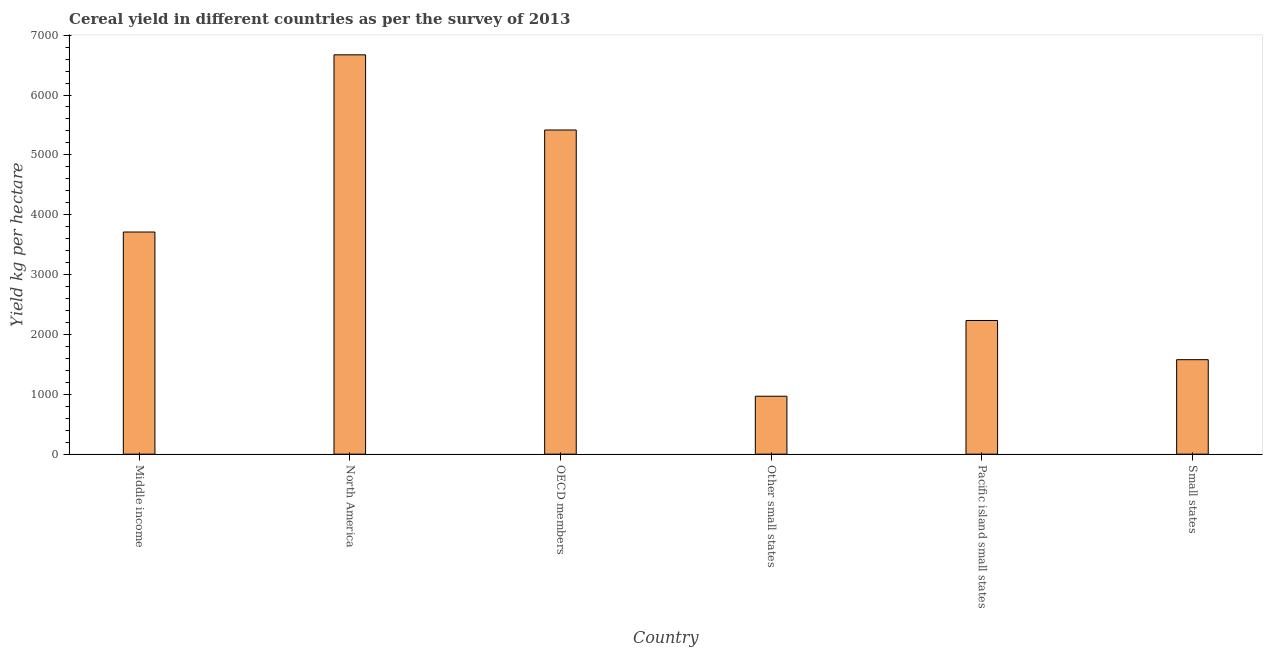Does the graph contain any zero values?
Ensure brevity in your answer.  No. Does the graph contain grids?
Provide a succinct answer. No. What is the title of the graph?
Your answer should be very brief. Cereal yield in different countries as per the survey of 2013. What is the label or title of the Y-axis?
Your answer should be compact. Yield kg per hectare. What is the cereal yield in Middle income?
Make the answer very short. 3710.98. Across all countries, what is the maximum cereal yield?
Ensure brevity in your answer.  6671.01. Across all countries, what is the minimum cereal yield?
Ensure brevity in your answer.  967.55. In which country was the cereal yield maximum?
Offer a very short reply. North America. In which country was the cereal yield minimum?
Offer a very short reply. Other small states. What is the sum of the cereal yield?
Make the answer very short. 2.06e+04. What is the difference between the cereal yield in Middle income and Pacific island small states?
Give a very brief answer. 1477.82. What is the average cereal yield per country?
Ensure brevity in your answer.  3429.4. What is the median cereal yield?
Make the answer very short. 2972.07. What is the ratio of the cereal yield in Middle income to that in Pacific island small states?
Make the answer very short. 1.66. Is the difference between the cereal yield in OECD members and Small states greater than the difference between any two countries?
Provide a succinct answer. No. What is the difference between the highest and the second highest cereal yield?
Provide a short and direct response. 1255.74. What is the difference between the highest and the lowest cereal yield?
Your response must be concise. 5703.47. In how many countries, is the cereal yield greater than the average cereal yield taken over all countries?
Provide a succinct answer. 3. How many countries are there in the graph?
Your response must be concise. 6. Are the values on the major ticks of Y-axis written in scientific E-notation?
Offer a very short reply. No. What is the Yield kg per hectare of Middle income?
Offer a very short reply. 3710.98. What is the Yield kg per hectare of North America?
Give a very brief answer. 6671.01. What is the Yield kg per hectare of OECD members?
Offer a very short reply. 5415.27. What is the Yield kg per hectare in Other small states?
Provide a short and direct response. 967.55. What is the Yield kg per hectare in Pacific island small states?
Keep it short and to the point. 2233.17. What is the Yield kg per hectare of Small states?
Give a very brief answer. 1578.43. What is the difference between the Yield kg per hectare in Middle income and North America?
Your answer should be compact. -2960.03. What is the difference between the Yield kg per hectare in Middle income and OECD members?
Ensure brevity in your answer.  -1704.29. What is the difference between the Yield kg per hectare in Middle income and Other small states?
Your response must be concise. 2743.44. What is the difference between the Yield kg per hectare in Middle income and Pacific island small states?
Give a very brief answer. 1477.82. What is the difference between the Yield kg per hectare in Middle income and Small states?
Provide a short and direct response. 2132.55. What is the difference between the Yield kg per hectare in North America and OECD members?
Keep it short and to the point. 1255.74. What is the difference between the Yield kg per hectare in North America and Other small states?
Offer a terse response. 5703.47. What is the difference between the Yield kg per hectare in North America and Pacific island small states?
Provide a short and direct response. 4437.85. What is the difference between the Yield kg per hectare in North America and Small states?
Your response must be concise. 5092.58. What is the difference between the Yield kg per hectare in OECD members and Other small states?
Ensure brevity in your answer.  4447.72. What is the difference between the Yield kg per hectare in OECD members and Pacific island small states?
Offer a very short reply. 3182.1. What is the difference between the Yield kg per hectare in OECD members and Small states?
Provide a succinct answer. 3836.84. What is the difference between the Yield kg per hectare in Other small states and Pacific island small states?
Offer a very short reply. -1265.62. What is the difference between the Yield kg per hectare in Other small states and Small states?
Give a very brief answer. -610.89. What is the difference between the Yield kg per hectare in Pacific island small states and Small states?
Keep it short and to the point. 654.73. What is the ratio of the Yield kg per hectare in Middle income to that in North America?
Provide a succinct answer. 0.56. What is the ratio of the Yield kg per hectare in Middle income to that in OECD members?
Your response must be concise. 0.69. What is the ratio of the Yield kg per hectare in Middle income to that in Other small states?
Your answer should be compact. 3.83. What is the ratio of the Yield kg per hectare in Middle income to that in Pacific island small states?
Offer a very short reply. 1.66. What is the ratio of the Yield kg per hectare in Middle income to that in Small states?
Your answer should be compact. 2.35. What is the ratio of the Yield kg per hectare in North America to that in OECD members?
Your answer should be very brief. 1.23. What is the ratio of the Yield kg per hectare in North America to that in Other small states?
Your answer should be very brief. 6.89. What is the ratio of the Yield kg per hectare in North America to that in Pacific island small states?
Give a very brief answer. 2.99. What is the ratio of the Yield kg per hectare in North America to that in Small states?
Offer a terse response. 4.23. What is the ratio of the Yield kg per hectare in OECD members to that in Other small states?
Ensure brevity in your answer.  5.6. What is the ratio of the Yield kg per hectare in OECD members to that in Pacific island small states?
Give a very brief answer. 2.42. What is the ratio of the Yield kg per hectare in OECD members to that in Small states?
Keep it short and to the point. 3.43. What is the ratio of the Yield kg per hectare in Other small states to that in Pacific island small states?
Give a very brief answer. 0.43. What is the ratio of the Yield kg per hectare in Other small states to that in Small states?
Your answer should be very brief. 0.61. What is the ratio of the Yield kg per hectare in Pacific island small states to that in Small states?
Provide a short and direct response. 1.42. 